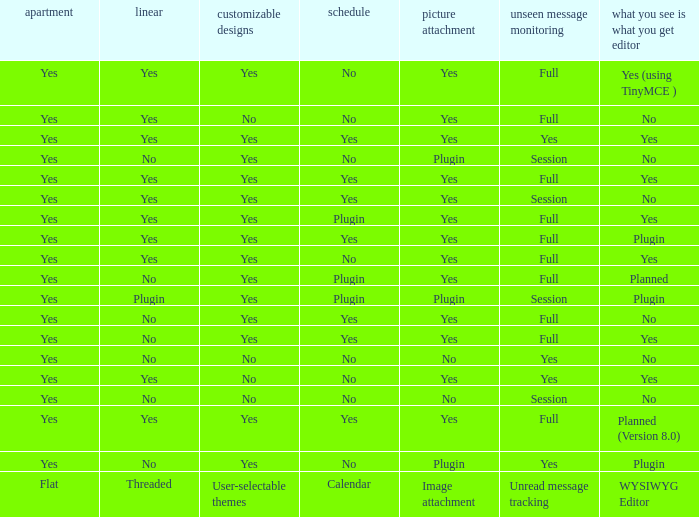Which Image attachment has a Threaded of yes, and a Calendar of yes? Yes, Yes, Yes, Yes, Yes. 